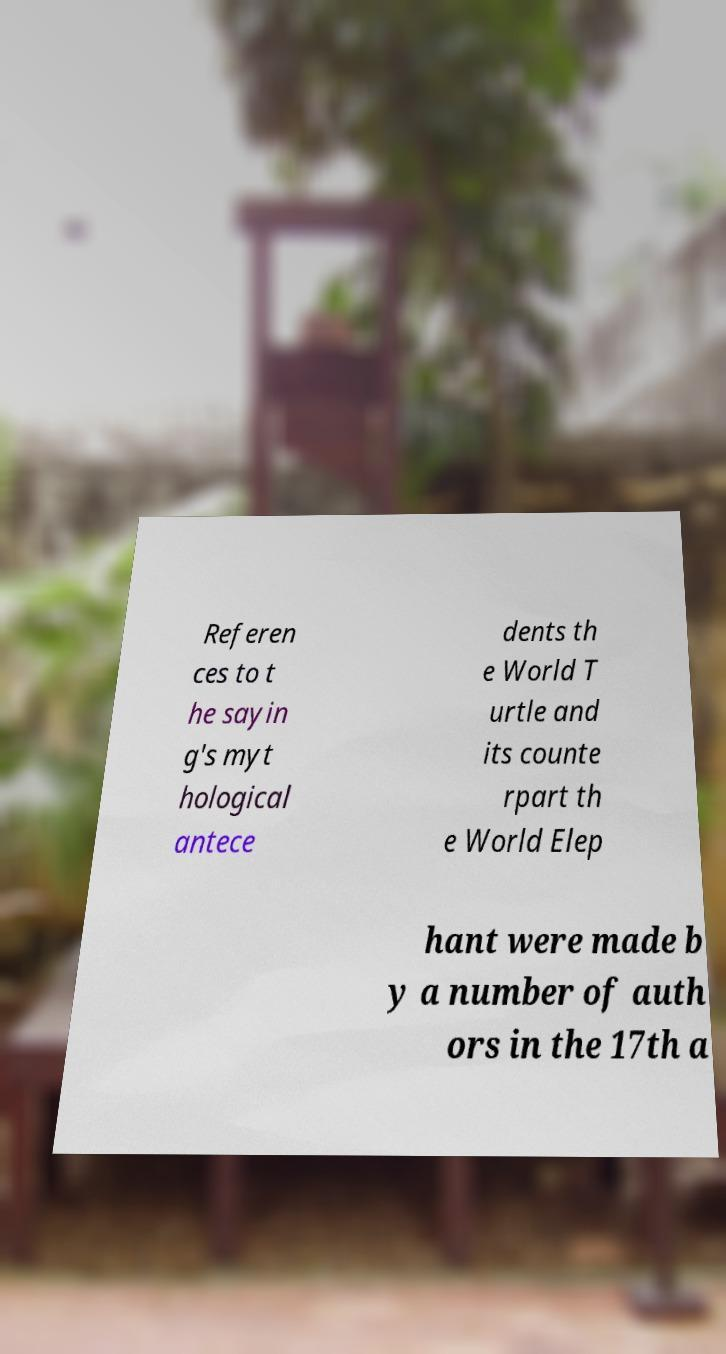For documentation purposes, I need the text within this image transcribed. Could you provide that? Referen ces to t he sayin g's myt hological antece dents th e World T urtle and its counte rpart th e World Elep hant were made b y a number of auth ors in the 17th a 